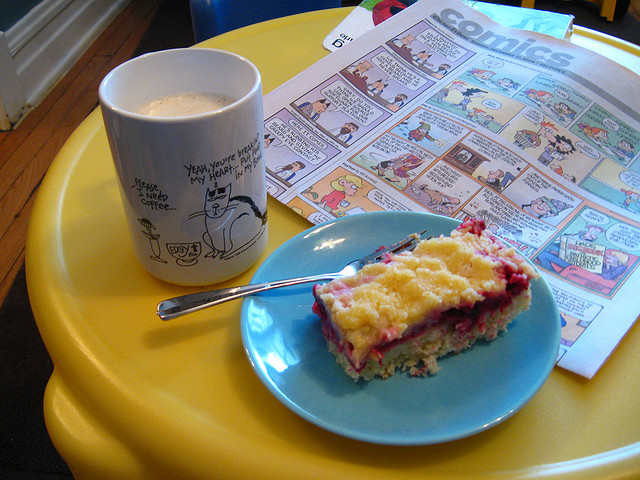Please transcribe the text in this image. Comics You're MY Please Coffee g Easy NEED I Heart IN MY Put break YEAH 